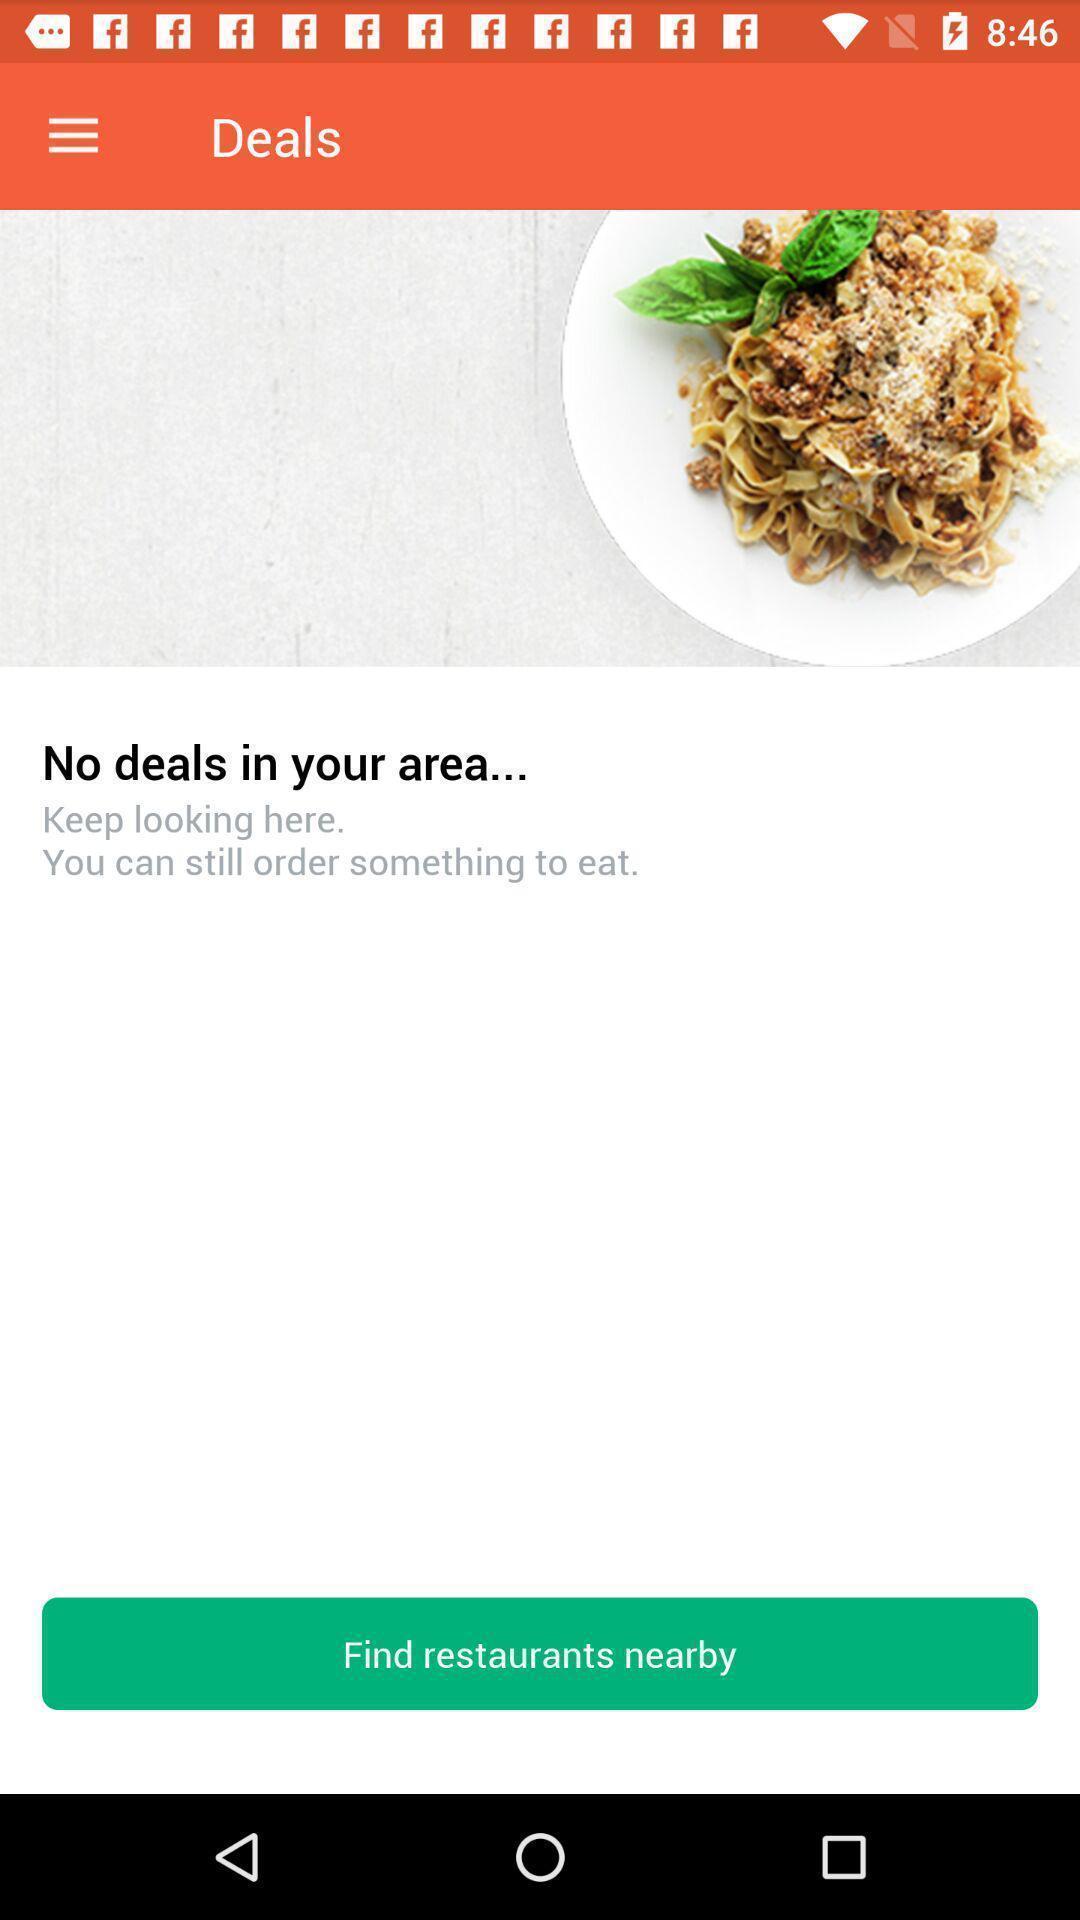Tell me about the visual elements in this screen capture. Screen showing no deals. 